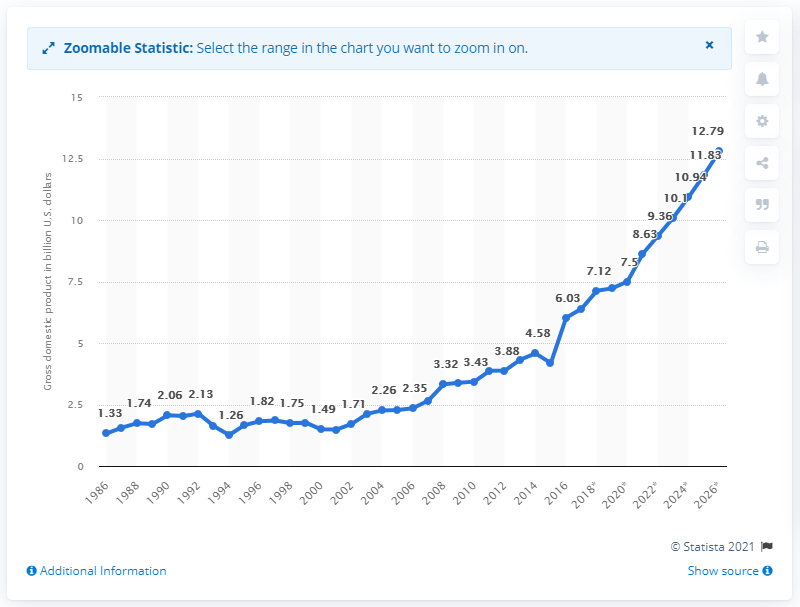List a handful of essential elements in this visual. In 2016, Togo's Gross Domestic Product was 6.03. 